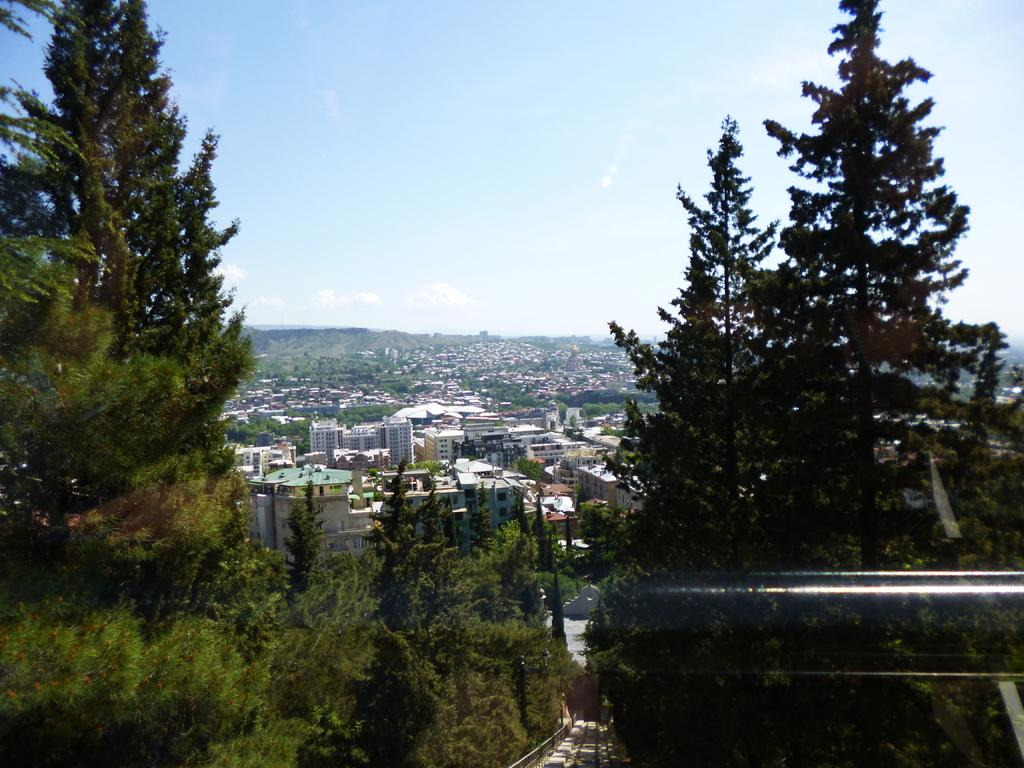What type of natural environment is depicted in the image? There are many trees in the image, indicating a natural environment. What can be seen in the background behind the trees? There is a city view visible behind the trees. What is the color of the sky in the image? The sky is blue in color. color. How many cups of thunder can be seen in the image? There are no cups or thunder present in the image. 